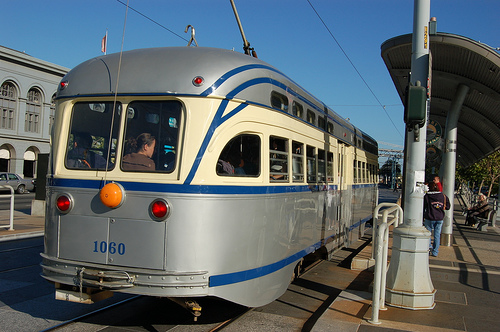<image>
Can you confirm if the light is next to the railing? No. The light is not positioned next to the railing. They are located in different areas of the scene. 